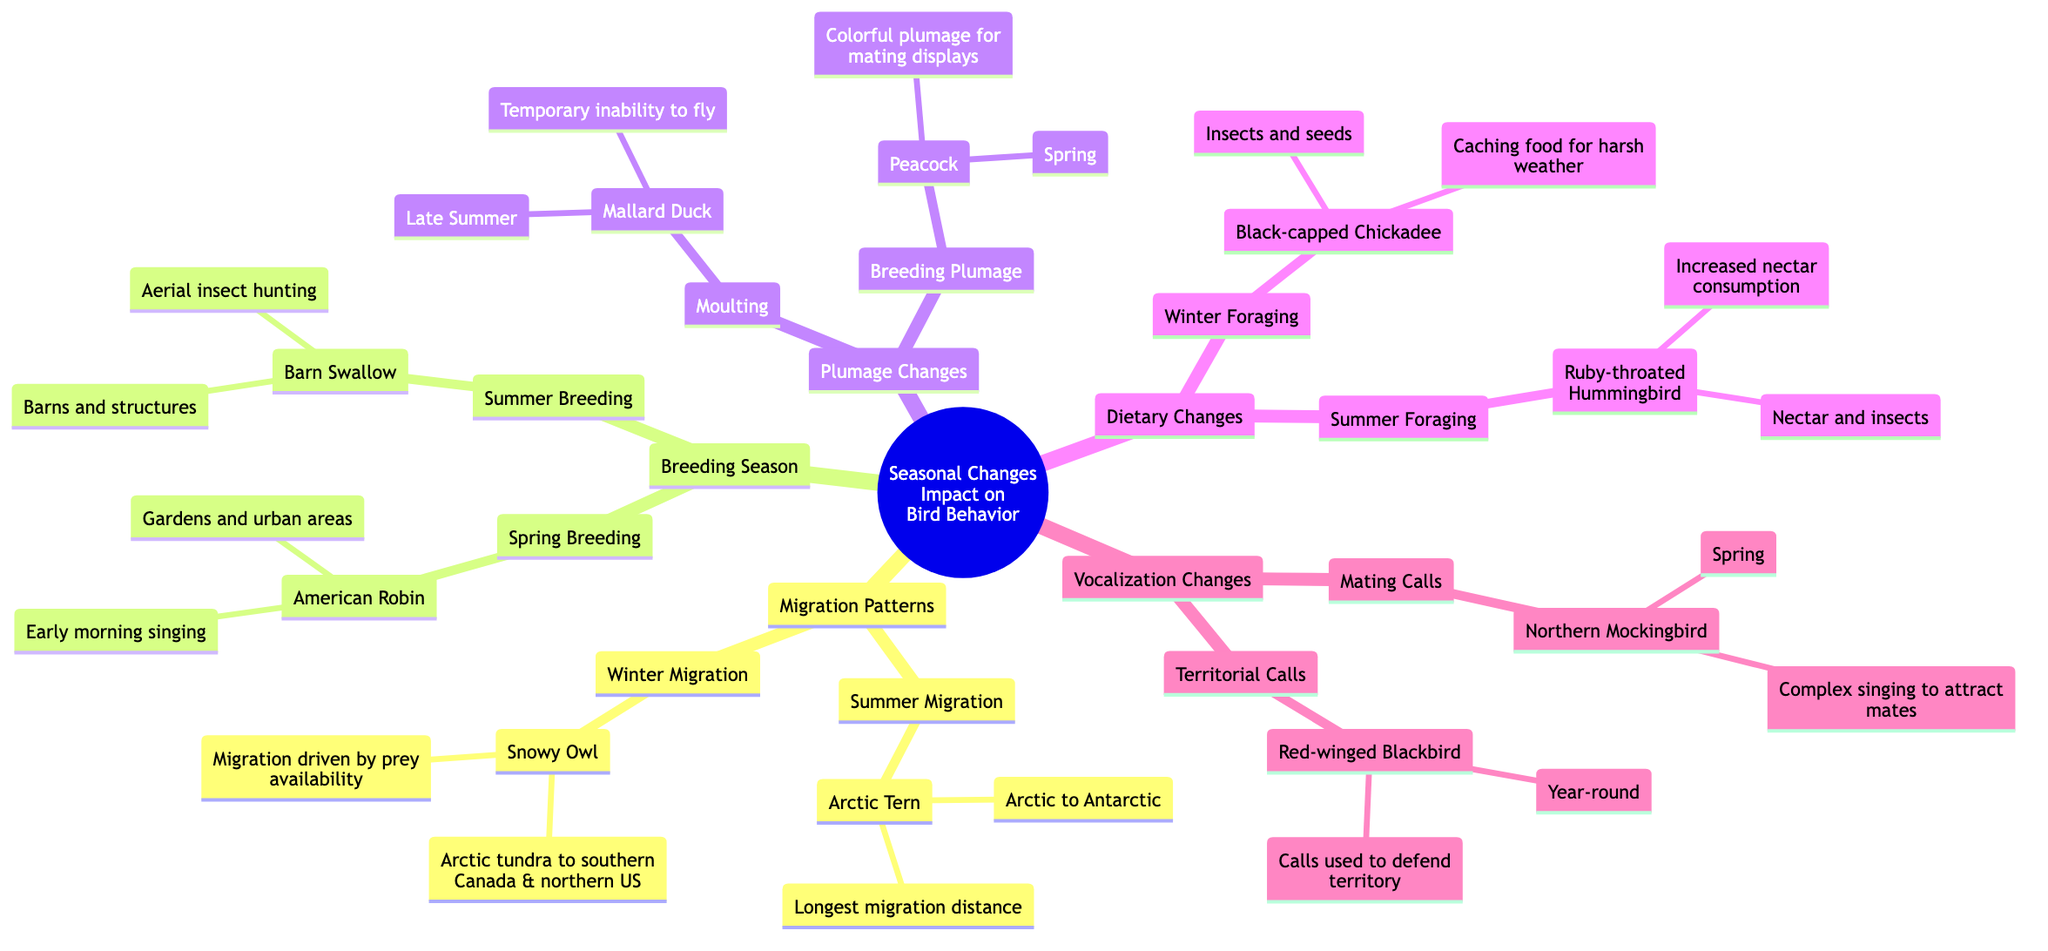What species migrates from Arctic to Antarctic? The diagram indicates that the species that migrates from Arctic to Antarctic during the summer migration is the Arctic Tern. The answer comes directly from the corresponding node labeled "Summer Migration" under "Migration Patterns."
Answer: Arctic Tern What is the nesting habitat of the American Robin? According to the diagram, the nesting habitat of the American Robin is defined under "Spring Breeding" in the "Breeding Season" section, where it states "Gardens and urban areas."
Answer: Gardens and urban areas How does the Snowy Owl's migration influence its behavior? From the diagram, we learn that the Snowy Owl's migration is driven by prey availability. This information is linked within the "Winter Migration" node, which contextualizes the behavioral aspect of this bird.
Answer: Migration driven by prey availability What seasonal change affects the Mallard Duck's ability to fly? The diagram shows that during "Moulting" in late summer, the Mallard Duck experiences a temporary inability to fly. This is specified under the node for "Plumage Changes" relating to the bird's behavior during that season.
Answer: Temporary inability to fly Which bird species increases nectar consumption during summer foraging? The diagram lists the Ruby-throated Hummingbird under "Summer Foraging," indicating that it consumes nectar and insects with increased levels due to high activity. The answer can be found in the section on dietary changes.
Answer: Ruby-throated Hummingbird What vocalization aspect does the Northern Mockingbird employ in spring? According to the diagram, the Northern Mockingbird engages in complex singing to attract mates during the spring, as highlighted in the "Mating Calls" section under "Vocalization Changes."
Answer: Complex singing to attract mates How many species are mentioned in the plumage changes section? A review of the diagram shows that there are two species mentioned in the "Plumage Changes" section: Mallard Duck and Peacock. This total is determined by counting the items listed under that particular node.
Answer: 2 What type of calls does the Red-winged Blackbird use year-round? The diagram specifies that the Red-winged Blackbird uses calls to defend territory throughout the year, which is detailed under the "Territorial Calls" node in the "Vocalization Changes" section.
Answer: Calls used to defend territory During which season do birds typically cache food for harsh weather? The diagram indicates that, during "Winter Foraging," the Black-capped Chickadee caches food to prepare for harsh weather conditions. This information is detailed in the dietary changes section.
Answer: Winter Foraging 